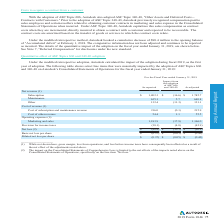According to Autodesk's financial document, What have been affected as a result of the net effect of the adjustments? gross margin, loss from operations, and loss before income taxes have consequently been affected as a result of the net effect of the adjustments noted above. The document states: "____________________ (1) While not shown here, gross margin, loss from operations, and loss before income taxes have consequently been affected as a r..." Also, What was the adjusted cost of subscription and maintenance revenue for fiscal year 2019? According to the financial document, 215.9. The relevant text states: "subscription and maintenance revenue 216.0 (0.1) 215.9 Cost of other revenue 54.4 1.1 55.5 Operating expenses (1):..." Also, What were the reported marketing and sales expenses? According to the financial document, 1,183.9. The relevant text states: "Marketing and sales 1,183.9 (17.9) 1,166.0 Provision for income taxes (38.1) (4.8) (42.9) Net loss (2) $ (80.8) $ (10.1) $ (90...." Also, can you calculate: What was the adjustment amount as a % of subscription net revenue? Based on the calculation: (16.6/1,802.3), the result is 0.92 (percentage). This is based on the information: "Subscription $ 1,802.3 $ (16.6) $ 1,785.7 Maintenance 635.1 5.7 640.8 Other 132.4 (11.3) 121.1 Cost of revenue (1) Subscription $ 1,802.3 $ (16.6) $ 1,785.7 Maintenance 635.1 5.7 640.8 Other 132.4 (11..." The key data points involved are: 1,802.3, 16.6. Also, can you calculate: What is other reported revenue as a % of total reported net revenue? To answer this question, I need to perform calculations using the financial data. The calculation is: (132.4/(1,802.3+635.1+132.4)), which equals 5.15 (percentage). This is based on the information: "Subscription $ 1,802.3 $ (16.6) $ 1,785.7 Maintenance 635.1 5.7 640.8 Other 132.4 (11.3) 121.1 Cost of revenue (1) 16.6) $ 1,785.7 Maintenance 635.1 5.7 640.8 Other 132.4 (11.3) 121.1 Cost of revenue ..." The key data points involved are: 1,802.3, 132.4, 635.1. Also, can you calculate: How much is total cost of revenue as reported? Based on the calculation: 216+54.4 , the result is 270.4 (in millions). This is based on the information: "Cost of subscription and maintenance revenue 216.0 (0.1) 215.9 Cost of other revenue 54.4 1.1 55.5 Operating expenses (1): e revenue 216.0 (0.1) 215.9 Cost of other revenue 54.4 1.1 55.5 Operating exp..." The key data points involved are: 216, 54.4. 